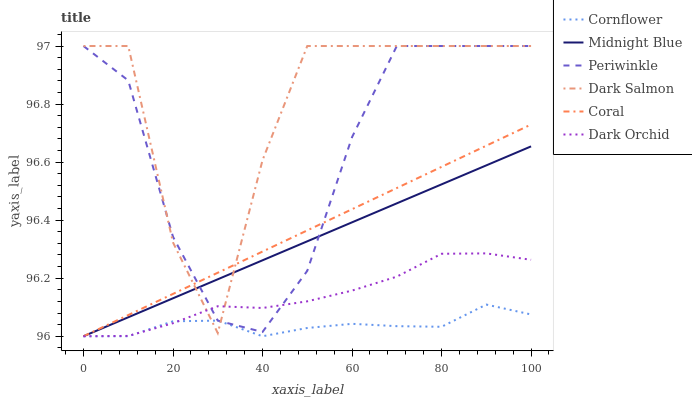Does Cornflower have the minimum area under the curve?
Answer yes or no. Yes. Does Dark Salmon have the maximum area under the curve?
Answer yes or no. Yes. Does Midnight Blue have the minimum area under the curve?
Answer yes or no. No. Does Midnight Blue have the maximum area under the curve?
Answer yes or no. No. Is Midnight Blue the smoothest?
Answer yes or no. Yes. Is Dark Salmon the roughest?
Answer yes or no. Yes. Is Dark Salmon the smoothest?
Answer yes or no. No. Is Coral the roughest?
Answer yes or no. No. Does Cornflower have the lowest value?
Answer yes or no. Yes. Does Dark Salmon have the lowest value?
Answer yes or no. No. Does Periwinkle have the highest value?
Answer yes or no. Yes. Does Midnight Blue have the highest value?
Answer yes or no. No. Does Dark Salmon intersect Coral?
Answer yes or no. Yes. Is Dark Salmon less than Coral?
Answer yes or no. No. Is Dark Salmon greater than Coral?
Answer yes or no. No. 